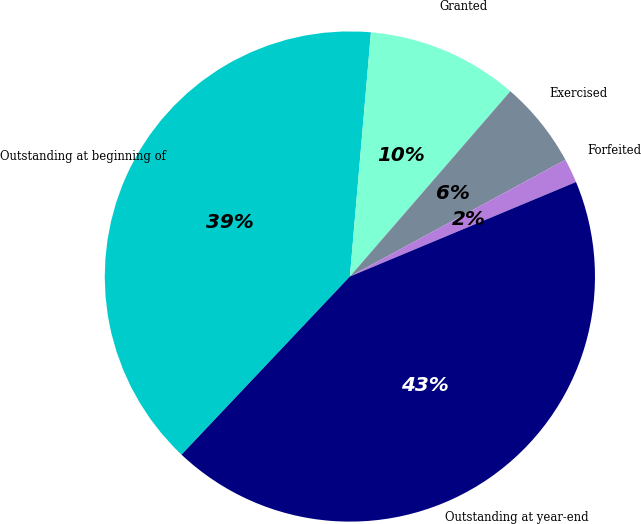Convert chart to OTSL. <chart><loc_0><loc_0><loc_500><loc_500><pie_chart><fcel>Outstanding at beginning of<fcel>Granted<fcel>Exercised<fcel>Forfeited<fcel>Outstanding at year-end<nl><fcel>39.32%<fcel>9.99%<fcel>5.74%<fcel>1.6%<fcel>43.35%<nl></chart> 